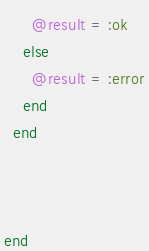Convert code to text. <code><loc_0><loc_0><loc_500><loc_500><_Ruby_>      @result = :ok
    else
      @result = :error
    end
  end



end
</code> 